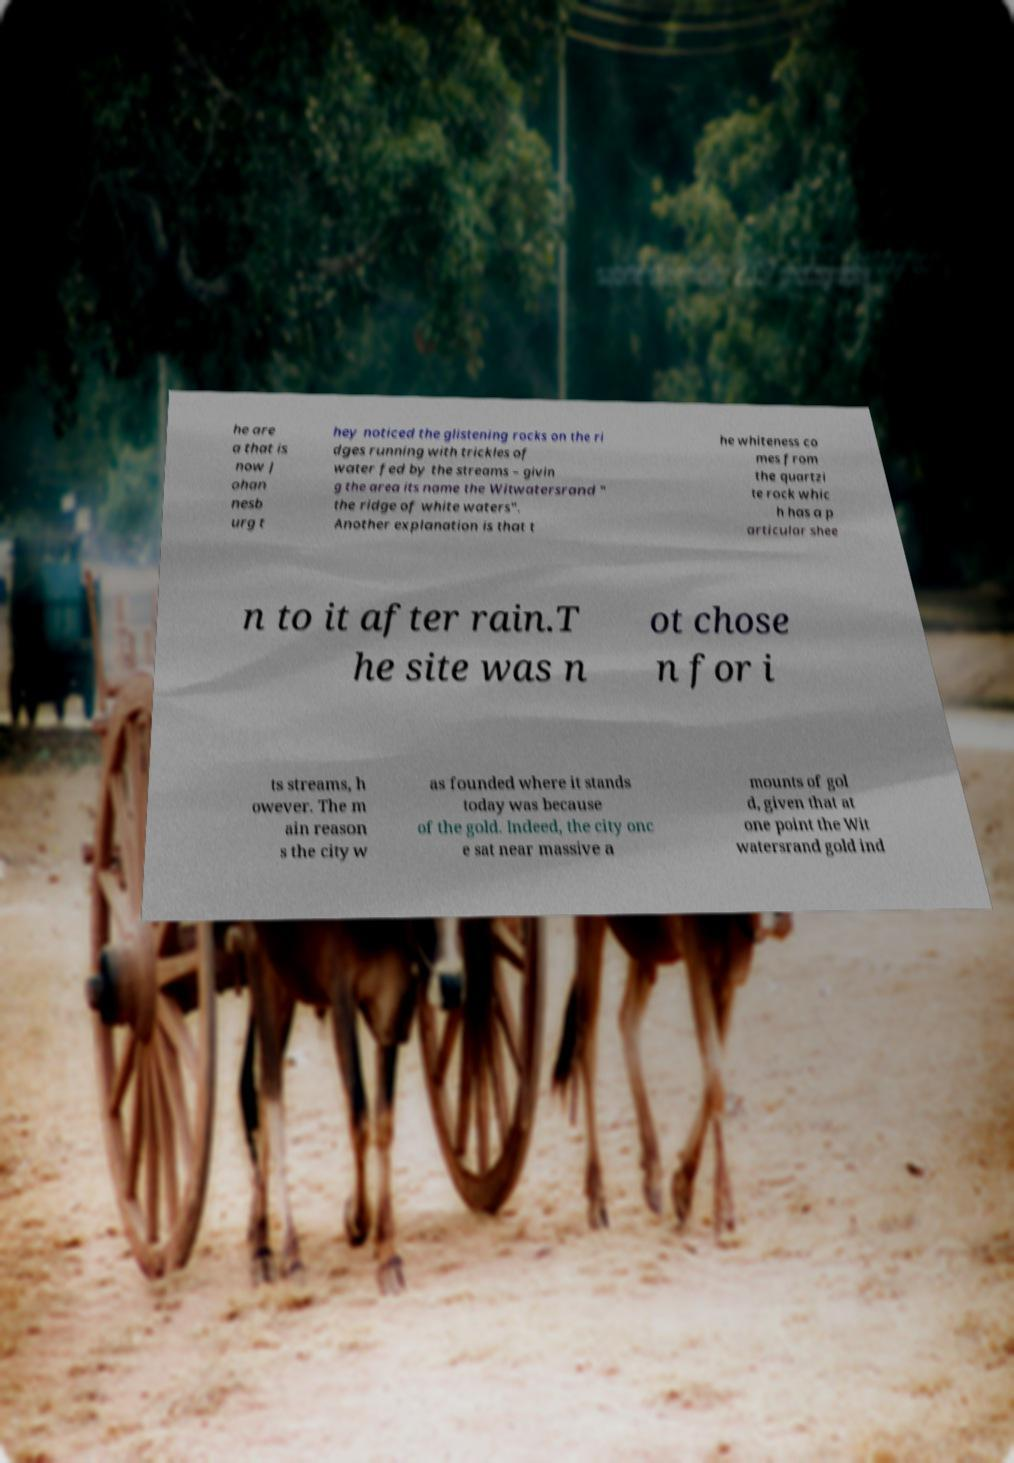There's text embedded in this image that I need extracted. Can you transcribe it verbatim? he are a that is now J ohan nesb urg t hey noticed the glistening rocks on the ri dges running with trickles of water fed by the streams – givin g the area its name the Witwatersrand " the ridge of white waters". Another explanation is that t he whiteness co mes from the quartzi te rock whic h has a p articular shee n to it after rain.T he site was n ot chose n for i ts streams, h owever. The m ain reason s the city w as founded where it stands today was because of the gold. Indeed, the city onc e sat near massive a mounts of gol d, given that at one point the Wit watersrand gold ind 